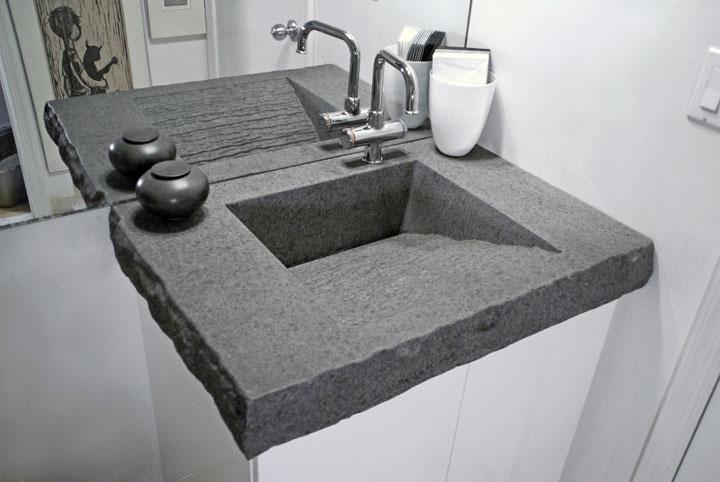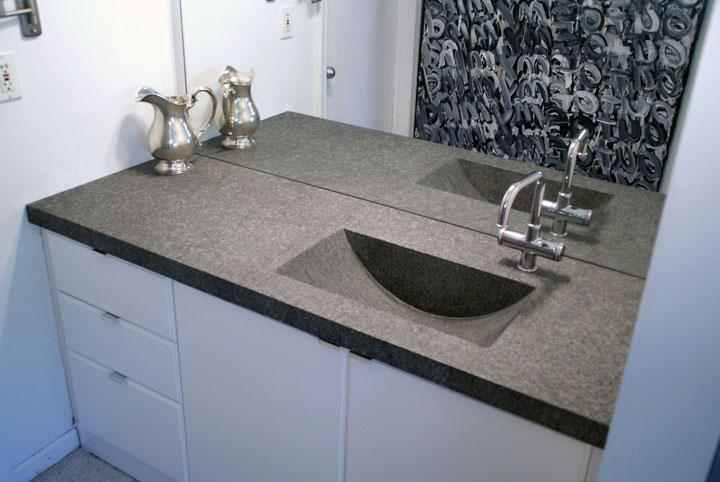The first image is the image on the left, the second image is the image on the right. For the images shown, is this caption "Each image shows a grey/silver vanity with only one sink." true? Answer yes or no. Yes. The first image is the image on the left, the second image is the image on the right. Considering the images on both sides, is "There are three faucets." valid? Answer yes or no. No. 